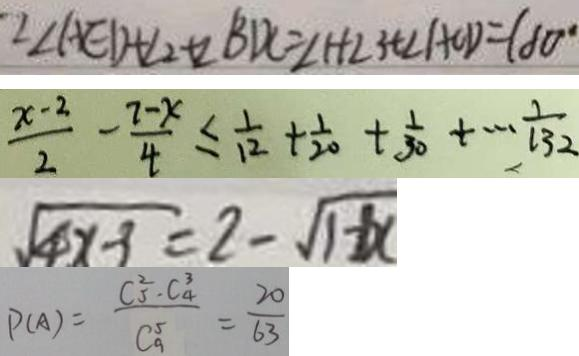<formula> <loc_0><loc_0><loc_500><loc_500>\because \angle A E D + \angle 2 + \angle B D C = \angle 1 + \angle 3 + \angle A C D = 1 8 0 ^ { \circ } 
 \frac { x - 2 } { 2 } - \frac { 7 - x } { 4 } \leq \frac { 1 } { 1 2 } + \frac { 1 } { 2 0 } + \frac { 1 } { 3 0 } + \cdots \frac { 1 } { 1 3 2 } 
 \sqrt { 4 x - 3 } = 2 - \sqrt { 1 + x } 
 P ( A ) = \frac { C ^ { 2 } _ { 5 } \cdot C _ { 4 } ^ { 3 } } { C _ { 9 } ^ { 5 } } = \frac { 2 0 } { 6 3 }</formula> 